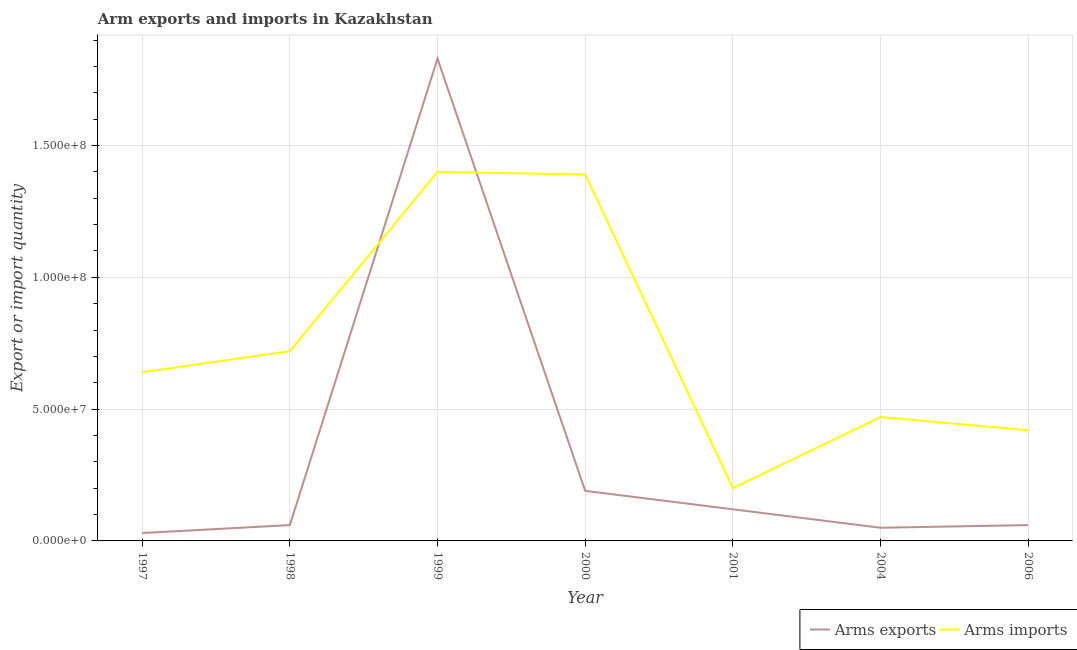How many different coloured lines are there?
Keep it short and to the point. 2. Does the line corresponding to arms exports intersect with the line corresponding to arms imports?
Your answer should be very brief. Yes. What is the arms imports in 1997?
Your answer should be compact. 6.40e+07. Across all years, what is the maximum arms exports?
Your answer should be very brief. 1.83e+08. Across all years, what is the minimum arms exports?
Offer a very short reply. 3.00e+06. In which year was the arms exports maximum?
Offer a terse response. 1999. In which year was the arms imports minimum?
Provide a short and direct response. 2001. What is the total arms exports in the graph?
Your answer should be very brief. 2.34e+08. What is the difference between the arms exports in 1999 and that in 2000?
Your response must be concise. 1.64e+08. What is the difference between the arms exports in 1997 and the arms imports in 1998?
Your answer should be very brief. -6.90e+07. What is the average arms imports per year?
Your response must be concise. 7.49e+07. In the year 2001, what is the difference between the arms exports and arms imports?
Offer a terse response. -8.00e+06. In how many years, is the arms imports greater than 140000000?
Provide a short and direct response. 0. What is the ratio of the arms imports in 2000 to that in 2001?
Offer a terse response. 6.95. Is the difference between the arms imports in 1997 and 1998 greater than the difference between the arms exports in 1997 and 1998?
Offer a terse response. No. What is the difference between the highest and the second highest arms imports?
Make the answer very short. 1.00e+06. What is the difference between the highest and the lowest arms imports?
Give a very brief answer. 1.20e+08. Is the sum of the arms exports in 1997 and 2001 greater than the maximum arms imports across all years?
Keep it short and to the point. No. Is the arms imports strictly less than the arms exports over the years?
Your response must be concise. No. How many lines are there?
Ensure brevity in your answer.  2. Does the graph contain any zero values?
Keep it short and to the point. No. Where does the legend appear in the graph?
Give a very brief answer. Bottom right. How many legend labels are there?
Your answer should be very brief. 2. What is the title of the graph?
Ensure brevity in your answer.  Arm exports and imports in Kazakhstan. Does "Primary income" appear as one of the legend labels in the graph?
Your answer should be compact. No. What is the label or title of the X-axis?
Your response must be concise. Year. What is the label or title of the Y-axis?
Your answer should be very brief. Export or import quantity. What is the Export or import quantity in Arms imports in 1997?
Keep it short and to the point. 6.40e+07. What is the Export or import quantity in Arms exports in 1998?
Offer a very short reply. 6.00e+06. What is the Export or import quantity of Arms imports in 1998?
Provide a succinct answer. 7.20e+07. What is the Export or import quantity in Arms exports in 1999?
Keep it short and to the point. 1.83e+08. What is the Export or import quantity in Arms imports in 1999?
Make the answer very short. 1.40e+08. What is the Export or import quantity in Arms exports in 2000?
Make the answer very short. 1.90e+07. What is the Export or import quantity of Arms imports in 2000?
Give a very brief answer. 1.39e+08. What is the Export or import quantity in Arms imports in 2004?
Offer a very short reply. 4.70e+07. What is the Export or import quantity in Arms exports in 2006?
Give a very brief answer. 6.00e+06. What is the Export or import quantity of Arms imports in 2006?
Offer a very short reply. 4.20e+07. Across all years, what is the maximum Export or import quantity of Arms exports?
Provide a short and direct response. 1.83e+08. Across all years, what is the maximum Export or import quantity of Arms imports?
Your answer should be very brief. 1.40e+08. Across all years, what is the minimum Export or import quantity in Arms exports?
Your answer should be compact. 3.00e+06. What is the total Export or import quantity of Arms exports in the graph?
Make the answer very short. 2.34e+08. What is the total Export or import quantity in Arms imports in the graph?
Your answer should be compact. 5.24e+08. What is the difference between the Export or import quantity in Arms exports in 1997 and that in 1998?
Keep it short and to the point. -3.00e+06. What is the difference between the Export or import quantity of Arms imports in 1997 and that in 1998?
Your answer should be very brief. -8.00e+06. What is the difference between the Export or import quantity in Arms exports in 1997 and that in 1999?
Ensure brevity in your answer.  -1.80e+08. What is the difference between the Export or import quantity in Arms imports in 1997 and that in 1999?
Your response must be concise. -7.60e+07. What is the difference between the Export or import quantity of Arms exports in 1997 and that in 2000?
Provide a short and direct response. -1.60e+07. What is the difference between the Export or import quantity in Arms imports in 1997 and that in 2000?
Give a very brief answer. -7.50e+07. What is the difference between the Export or import quantity of Arms exports in 1997 and that in 2001?
Your answer should be compact. -9.00e+06. What is the difference between the Export or import quantity of Arms imports in 1997 and that in 2001?
Offer a terse response. 4.40e+07. What is the difference between the Export or import quantity of Arms imports in 1997 and that in 2004?
Your answer should be compact. 1.70e+07. What is the difference between the Export or import quantity of Arms exports in 1997 and that in 2006?
Offer a very short reply. -3.00e+06. What is the difference between the Export or import quantity in Arms imports in 1997 and that in 2006?
Your response must be concise. 2.20e+07. What is the difference between the Export or import quantity of Arms exports in 1998 and that in 1999?
Provide a short and direct response. -1.77e+08. What is the difference between the Export or import quantity of Arms imports in 1998 and that in 1999?
Keep it short and to the point. -6.80e+07. What is the difference between the Export or import quantity in Arms exports in 1998 and that in 2000?
Give a very brief answer. -1.30e+07. What is the difference between the Export or import quantity of Arms imports in 1998 and that in 2000?
Keep it short and to the point. -6.70e+07. What is the difference between the Export or import quantity in Arms exports in 1998 and that in 2001?
Provide a succinct answer. -6.00e+06. What is the difference between the Export or import quantity of Arms imports in 1998 and that in 2001?
Your answer should be compact. 5.20e+07. What is the difference between the Export or import quantity of Arms imports in 1998 and that in 2004?
Provide a succinct answer. 2.50e+07. What is the difference between the Export or import quantity in Arms imports in 1998 and that in 2006?
Give a very brief answer. 3.00e+07. What is the difference between the Export or import quantity in Arms exports in 1999 and that in 2000?
Your response must be concise. 1.64e+08. What is the difference between the Export or import quantity in Arms exports in 1999 and that in 2001?
Provide a short and direct response. 1.71e+08. What is the difference between the Export or import quantity of Arms imports in 1999 and that in 2001?
Provide a short and direct response. 1.20e+08. What is the difference between the Export or import quantity in Arms exports in 1999 and that in 2004?
Offer a terse response. 1.78e+08. What is the difference between the Export or import quantity in Arms imports in 1999 and that in 2004?
Offer a terse response. 9.30e+07. What is the difference between the Export or import quantity in Arms exports in 1999 and that in 2006?
Keep it short and to the point. 1.77e+08. What is the difference between the Export or import quantity of Arms imports in 1999 and that in 2006?
Your answer should be compact. 9.80e+07. What is the difference between the Export or import quantity in Arms exports in 2000 and that in 2001?
Make the answer very short. 7.00e+06. What is the difference between the Export or import quantity in Arms imports in 2000 and that in 2001?
Offer a terse response. 1.19e+08. What is the difference between the Export or import quantity of Arms exports in 2000 and that in 2004?
Provide a short and direct response. 1.40e+07. What is the difference between the Export or import quantity of Arms imports in 2000 and that in 2004?
Ensure brevity in your answer.  9.20e+07. What is the difference between the Export or import quantity in Arms exports in 2000 and that in 2006?
Your answer should be compact. 1.30e+07. What is the difference between the Export or import quantity in Arms imports in 2000 and that in 2006?
Make the answer very short. 9.70e+07. What is the difference between the Export or import quantity of Arms imports in 2001 and that in 2004?
Offer a very short reply. -2.70e+07. What is the difference between the Export or import quantity of Arms exports in 2001 and that in 2006?
Your answer should be compact. 6.00e+06. What is the difference between the Export or import quantity in Arms imports in 2001 and that in 2006?
Your response must be concise. -2.20e+07. What is the difference between the Export or import quantity of Arms exports in 2004 and that in 2006?
Offer a terse response. -1.00e+06. What is the difference between the Export or import quantity of Arms imports in 2004 and that in 2006?
Your answer should be compact. 5.00e+06. What is the difference between the Export or import quantity in Arms exports in 1997 and the Export or import quantity in Arms imports in 1998?
Offer a terse response. -6.90e+07. What is the difference between the Export or import quantity in Arms exports in 1997 and the Export or import quantity in Arms imports in 1999?
Provide a short and direct response. -1.37e+08. What is the difference between the Export or import quantity of Arms exports in 1997 and the Export or import quantity of Arms imports in 2000?
Your answer should be compact. -1.36e+08. What is the difference between the Export or import quantity of Arms exports in 1997 and the Export or import quantity of Arms imports in 2001?
Your response must be concise. -1.70e+07. What is the difference between the Export or import quantity in Arms exports in 1997 and the Export or import quantity in Arms imports in 2004?
Make the answer very short. -4.40e+07. What is the difference between the Export or import quantity of Arms exports in 1997 and the Export or import quantity of Arms imports in 2006?
Make the answer very short. -3.90e+07. What is the difference between the Export or import quantity of Arms exports in 1998 and the Export or import quantity of Arms imports in 1999?
Provide a short and direct response. -1.34e+08. What is the difference between the Export or import quantity of Arms exports in 1998 and the Export or import quantity of Arms imports in 2000?
Provide a succinct answer. -1.33e+08. What is the difference between the Export or import quantity in Arms exports in 1998 and the Export or import quantity in Arms imports in 2001?
Make the answer very short. -1.40e+07. What is the difference between the Export or import quantity in Arms exports in 1998 and the Export or import quantity in Arms imports in 2004?
Give a very brief answer. -4.10e+07. What is the difference between the Export or import quantity in Arms exports in 1998 and the Export or import quantity in Arms imports in 2006?
Make the answer very short. -3.60e+07. What is the difference between the Export or import quantity in Arms exports in 1999 and the Export or import quantity in Arms imports in 2000?
Make the answer very short. 4.40e+07. What is the difference between the Export or import quantity in Arms exports in 1999 and the Export or import quantity in Arms imports in 2001?
Your response must be concise. 1.63e+08. What is the difference between the Export or import quantity in Arms exports in 1999 and the Export or import quantity in Arms imports in 2004?
Keep it short and to the point. 1.36e+08. What is the difference between the Export or import quantity of Arms exports in 1999 and the Export or import quantity of Arms imports in 2006?
Your response must be concise. 1.41e+08. What is the difference between the Export or import quantity of Arms exports in 2000 and the Export or import quantity of Arms imports in 2004?
Offer a terse response. -2.80e+07. What is the difference between the Export or import quantity in Arms exports in 2000 and the Export or import quantity in Arms imports in 2006?
Ensure brevity in your answer.  -2.30e+07. What is the difference between the Export or import quantity in Arms exports in 2001 and the Export or import quantity in Arms imports in 2004?
Give a very brief answer. -3.50e+07. What is the difference between the Export or import quantity in Arms exports in 2001 and the Export or import quantity in Arms imports in 2006?
Ensure brevity in your answer.  -3.00e+07. What is the difference between the Export or import quantity in Arms exports in 2004 and the Export or import quantity in Arms imports in 2006?
Keep it short and to the point. -3.70e+07. What is the average Export or import quantity in Arms exports per year?
Provide a short and direct response. 3.34e+07. What is the average Export or import quantity of Arms imports per year?
Offer a terse response. 7.49e+07. In the year 1997, what is the difference between the Export or import quantity in Arms exports and Export or import quantity in Arms imports?
Provide a short and direct response. -6.10e+07. In the year 1998, what is the difference between the Export or import quantity in Arms exports and Export or import quantity in Arms imports?
Ensure brevity in your answer.  -6.60e+07. In the year 1999, what is the difference between the Export or import quantity of Arms exports and Export or import quantity of Arms imports?
Make the answer very short. 4.30e+07. In the year 2000, what is the difference between the Export or import quantity of Arms exports and Export or import quantity of Arms imports?
Make the answer very short. -1.20e+08. In the year 2001, what is the difference between the Export or import quantity of Arms exports and Export or import quantity of Arms imports?
Make the answer very short. -8.00e+06. In the year 2004, what is the difference between the Export or import quantity of Arms exports and Export or import quantity of Arms imports?
Give a very brief answer. -4.20e+07. In the year 2006, what is the difference between the Export or import quantity in Arms exports and Export or import quantity in Arms imports?
Offer a very short reply. -3.60e+07. What is the ratio of the Export or import quantity in Arms exports in 1997 to that in 1998?
Provide a succinct answer. 0.5. What is the ratio of the Export or import quantity of Arms imports in 1997 to that in 1998?
Provide a succinct answer. 0.89. What is the ratio of the Export or import quantity of Arms exports in 1997 to that in 1999?
Offer a terse response. 0.02. What is the ratio of the Export or import quantity of Arms imports in 1997 to that in 1999?
Make the answer very short. 0.46. What is the ratio of the Export or import quantity of Arms exports in 1997 to that in 2000?
Ensure brevity in your answer.  0.16. What is the ratio of the Export or import quantity of Arms imports in 1997 to that in 2000?
Your answer should be very brief. 0.46. What is the ratio of the Export or import quantity of Arms exports in 1997 to that in 2001?
Provide a succinct answer. 0.25. What is the ratio of the Export or import quantity in Arms exports in 1997 to that in 2004?
Provide a short and direct response. 0.6. What is the ratio of the Export or import quantity in Arms imports in 1997 to that in 2004?
Keep it short and to the point. 1.36. What is the ratio of the Export or import quantity in Arms exports in 1997 to that in 2006?
Provide a succinct answer. 0.5. What is the ratio of the Export or import quantity of Arms imports in 1997 to that in 2006?
Ensure brevity in your answer.  1.52. What is the ratio of the Export or import quantity of Arms exports in 1998 to that in 1999?
Provide a short and direct response. 0.03. What is the ratio of the Export or import quantity of Arms imports in 1998 to that in 1999?
Give a very brief answer. 0.51. What is the ratio of the Export or import quantity in Arms exports in 1998 to that in 2000?
Offer a very short reply. 0.32. What is the ratio of the Export or import quantity in Arms imports in 1998 to that in 2000?
Keep it short and to the point. 0.52. What is the ratio of the Export or import quantity in Arms imports in 1998 to that in 2001?
Your answer should be very brief. 3.6. What is the ratio of the Export or import quantity in Arms exports in 1998 to that in 2004?
Offer a terse response. 1.2. What is the ratio of the Export or import quantity of Arms imports in 1998 to that in 2004?
Keep it short and to the point. 1.53. What is the ratio of the Export or import quantity of Arms exports in 1998 to that in 2006?
Provide a succinct answer. 1. What is the ratio of the Export or import quantity in Arms imports in 1998 to that in 2006?
Your answer should be very brief. 1.71. What is the ratio of the Export or import quantity of Arms exports in 1999 to that in 2000?
Provide a succinct answer. 9.63. What is the ratio of the Export or import quantity in Arms imports in 1999 to that in 2000?
Offer a very short reply. 1.01. What is the ratio of the Export or import quantity in Arms exports in 1999 to that in 2001?
Keep it short and to the point. 15.25. What is the ratio of the Export or import quantity of Arms imports in 1999 to that in 2001?
Your answer should be compact. 7. What is the ratio of the Export or import quantity in Arms exports in 1999 to that in 2004?
Your answer should be compact. 36.6. What is the ratio of the Export or import quantity of Arms imports in 1999 to that in 2004?
Ensure brevity in your answer.  2.98. What is the ratio of the Export or import quantity in Arms exports in 1999 to that in 2006?
Give a very brief answer. 30.5. What is the ratio of the Export or import quantity in Arms exports in 2000 to that in 2001?
Offer a terse response. 1.58. What is the ratio of the Export or import quantity of Arms imports in 2000 to that in 2001?
Your answer should be compact. 6.95. What is the ratio of the Export or import quantity in Arms imports in 2000 to that in 2004?
Ensure brevity in your answer.  2.96. What is the ratio of the Export or import quantity in Arms exports in 2000 to that in 2006?
Offer a very short reply. 3.17. What is the ratio of the Export or import quantity of Arms imports in 2000 to that in 2006?
Your answer should be compact. 3.31. What is the ratio of the Export or import quantity in Arms imports in 2001 to that in 2004?
Your answer should be very brief. 0.43. What is the ratio of the Export or import quantity in Arms exports in 2001 to that in 2006?
Your answer should be very brief. 2. What is the ratio of the Export or import quantity in Arms imports in 2001 to that in 2006?
Offer a very short reply. 0.48. What is the ratio of the Export or import quantity of Arms imports in 2004 to that in 2006?
Your answer should be compact. 1.12. What is the difference between the highest and the second highest Export or import quantity in Arms exports?
Your response must be concise. 1.64e+08. What is the difference between the highest and the second highest Export or import quantity of Arms imports?
Your answer should be compact. 1.00e+06. What is the difference between the highest and the lowest Export or import quantity of Arms exports?
Offer a very short reply. 1.80e+08. What is the difference between the highest and the lowest Export or import quantity of Arms imports?
Give a very brief answer. 1.20e+08. 